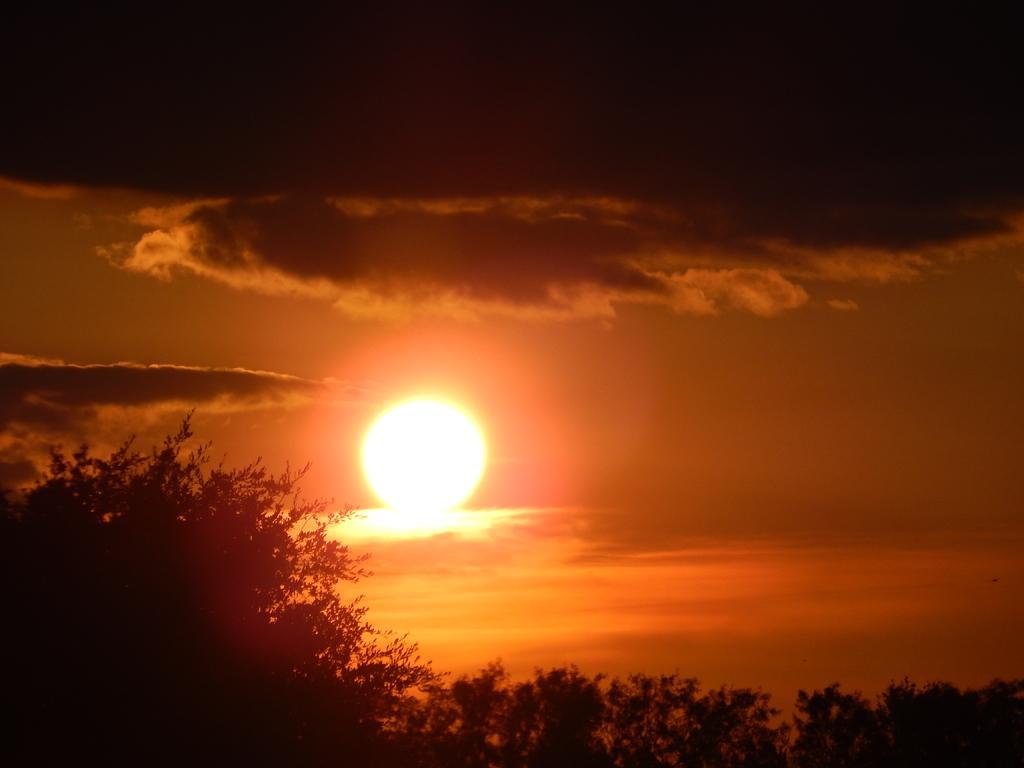Could you give a brief overview of what you see in this image? In this image there are trees, at the top of the image there is sun and clouds in the sky. 